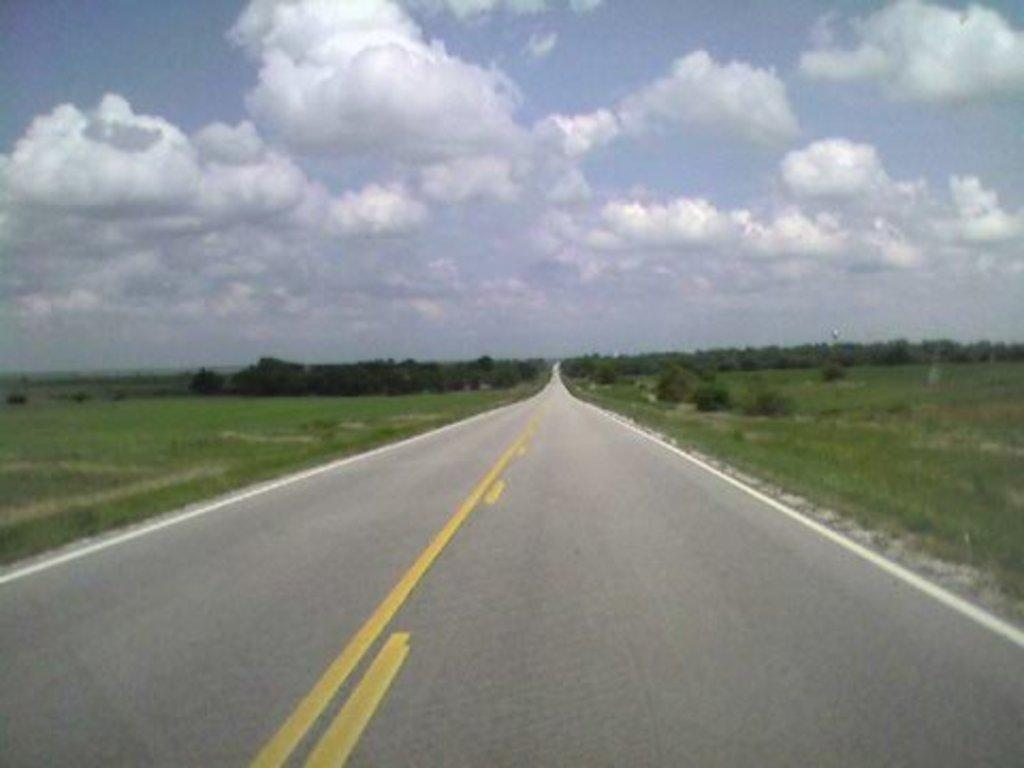What is the main feature of the image? There is a road in the image. Can you describe the road in more detail? The road has margins. What type of vegetation can be seen in the image? There is grass, trees, and small bushes in the image. What is visible in the sky? There are clouds in the sky. What type of flag is being waved by the goat in the park? There is no goat or flag present in the image. The image features a road with margins, grass, trees, small bushes, and clouds in the sky. 